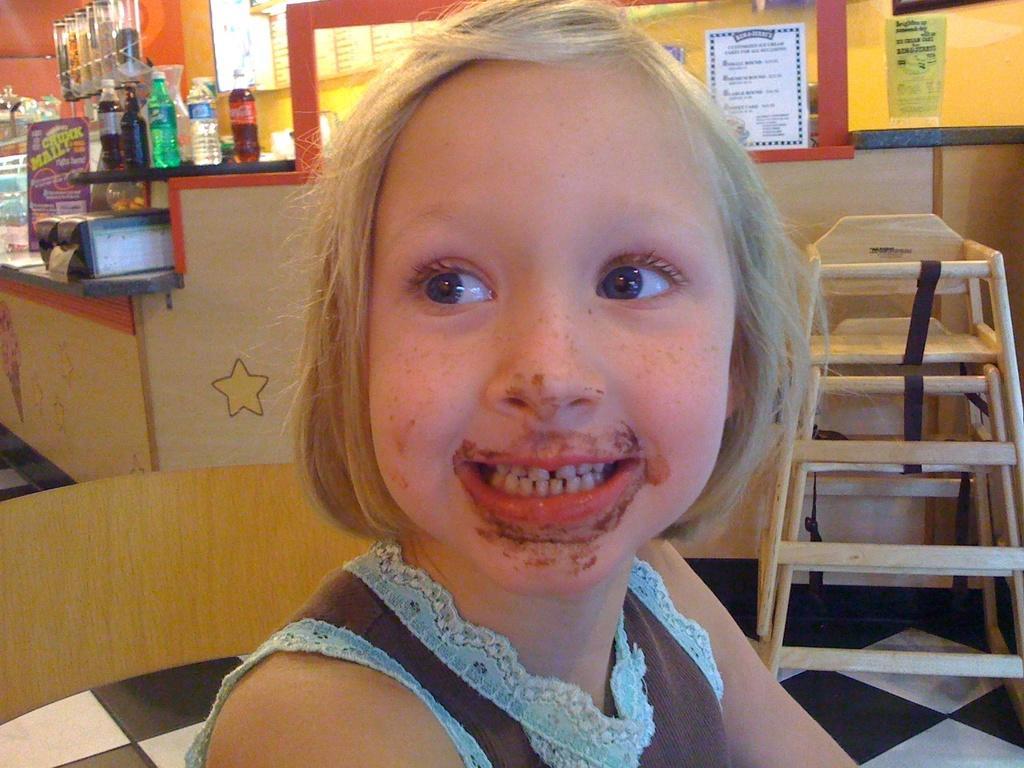Could you give a brief overview of what you see in this image? There is a girl sitting on chair and smiling. In the background we can see chair and we can see bottles and objects on tables. We can see wall,posters on glass and objects in shelf. 